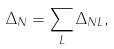<formula> <loc_0><loc_0><loc_500><loc_500>\Delta _ { N } = \sum _ { L } \Delta _ { N L } ,</formula> 